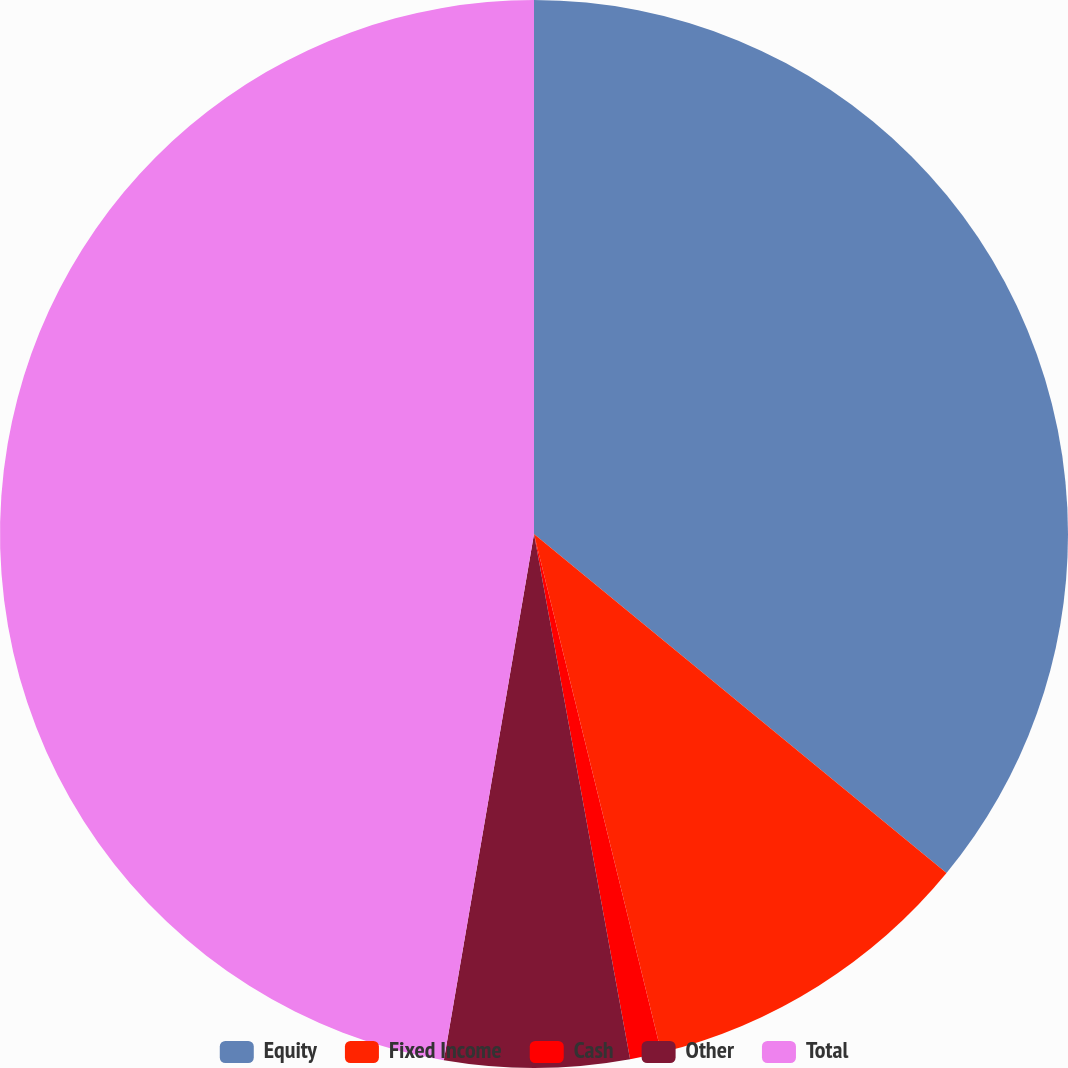Convert chart to OTSL. <chart><loc_0><loc_0><loc_500><loc_500><pie_chart><fcel>Equity<fcel>Fixed Income<fcel>Cash<fcel>Other<fcel>Total<nl><fcel>35.95%<fcel>10.22%<fcel>0.95%<fcel>5.58%<fcel>47.3%<nl></chart> 